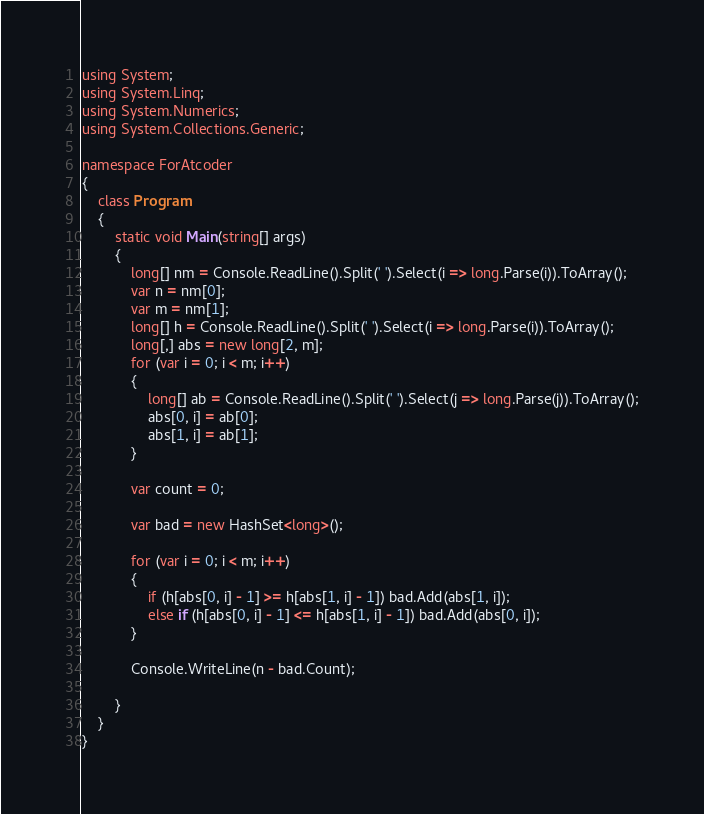Convert code to text. <code><loc_0><loc_0><loc_500><loc_500><_C#_>using System;
using System.Linq;
using System.Numerics;
using System.Collections.Generic;

namespace ForAtcoder
{
    class Program
    {
        static void Main(string[] args)
        {
            long[] nm = Console.ReadLine().Split(' ').Select(i => long.Parse(i)).ToArray();
            var n = nm[0];
            var m = nm[1];
            long[] h = Console.ReadLine().Split(' ').Select(i => long.Parse(i)).ToArray();
            long[,] abs = new long[2, m];
            for (var i = 0; i < m; i++)
            {
                long[] ab = Console.ReadLine().Split(' ').Select(j => long.Parse(j)).ToArray();
                abs[0, i] = ab[0];
                abs[1, i] = ab[1];
            }

            var count = 0;

            var bad = new HashSet<long>();

            for (var i = 0; i < m; i++)
            {
                if (h[abs[0, i] - 1] >= h[abs[1, i] - 1]) bad.Add(abs[1, i]);
                else if (h[abs[0, i] - 1] <= h[abs[1, i] - 1]) bad.Add(abs[0, i]);
            }

            Console.WriteLine(n - bad.Count); 

        }
    }
}</code> 